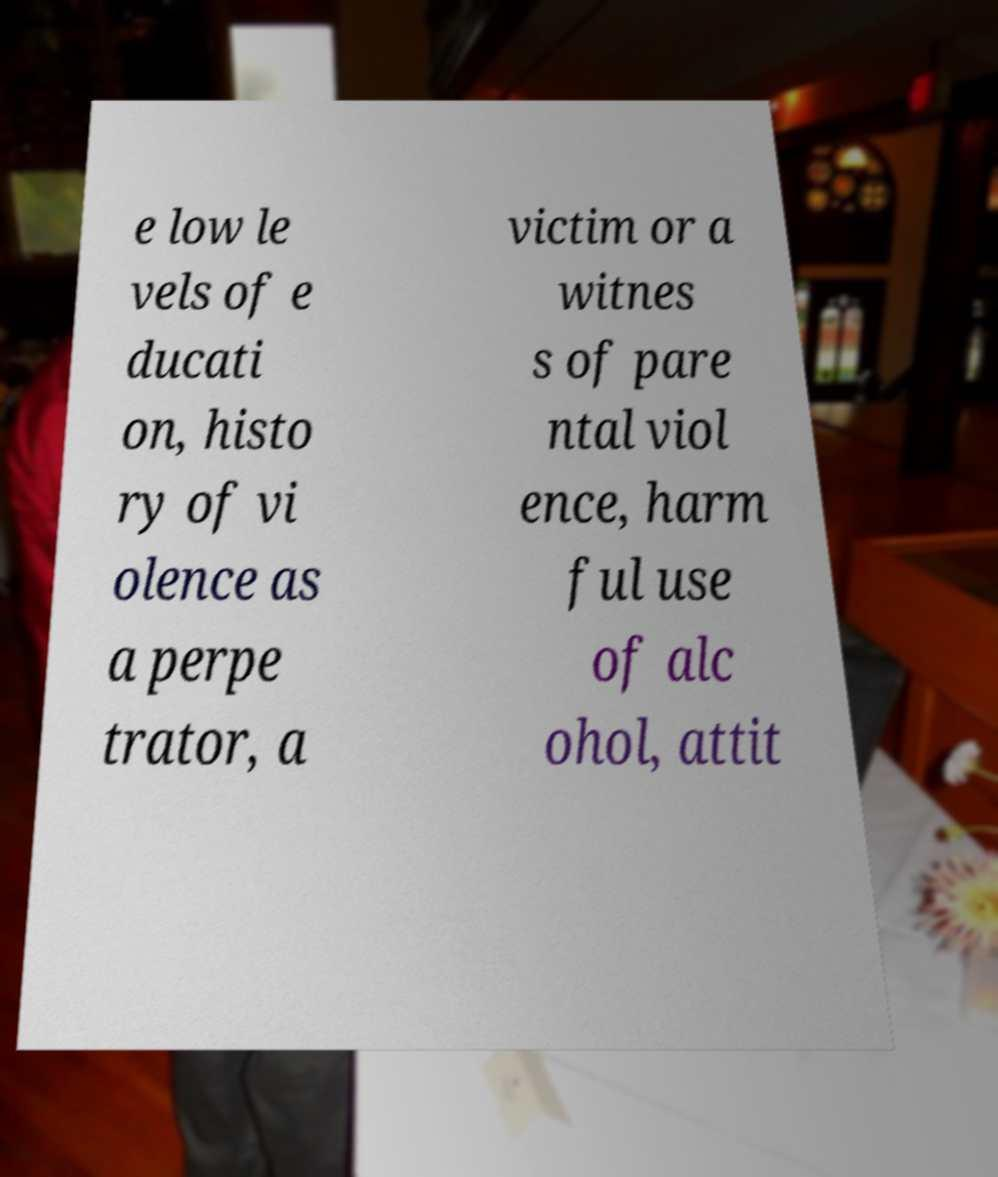Could you extract and type out the text from this image? e low le vels of e ducati on, histo ry of vi olence as a perpe trator, a victim or a witnes s of pare ntal viol ence, harm ful use of alc ohol, attit 